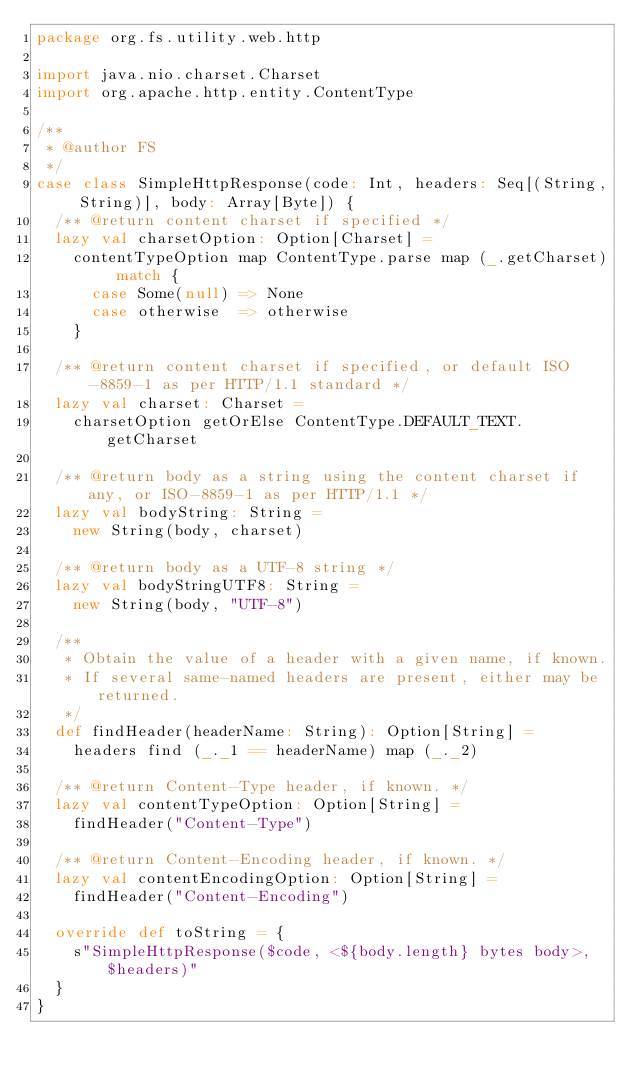Convert code to text. <code><loc_0><loc_0><loc_500><loc_500><_Scala_>package org.fs.utility.web.http

import java.nio.charset.Charset
import org.apache.http.entity.ContentType

/**
 * @author FS
 */
case class SimpleHttpResponse(code: Int, headers: Seq[(String, String)], body: Array[Byte]) {
  /** @return content charset if specified */
  lazy val charsetOption: Option[Charset] =
    contentTypeOption map ContentType.parse map (_.getCharset) match {
      case Some(null) => None
      case otherwise  => otherwise
    }

  /** @return content charset if specified, or default ISO-8859-1 as per HTTP/1.1 standard */
  lazy val charset: Charset =
    charsetOption getOrElse ContentType.DEFAULT_TEXT.getCharset

  /** @return body as a string using the content charset if any, or ISO-8859-1 as per HTTP/1.1 */
  lazy val bodyString: String =
    new String(body, charset)

  /** @return body as a UTF-8 string */
  lazy val bodyStringUTF8: String =
    new String(body, "UTF-8")

  /**
   * Obtain the value of a header with a given name, if known.
   * If several same-named headers are present, either may be returned.
   */
  def findHeader(headerName: String): Option[String] =
    headers find (_._1 == headerName) map (_._2)

  /** @return Content-Type header, if known. */
  lazy val contentTypeOption: Option[String] =
    findHeader("Content-Type")

  /** @return Content-Encoding header, if known. */
  lazy val contentEncodingOption: Option[String] =
    findHeader("Content-Encoding")

  override def toString = {
    s"SimpleHttpResponse($code, <${body.length} bytes body>, $headers)"
  }
}
</code> 